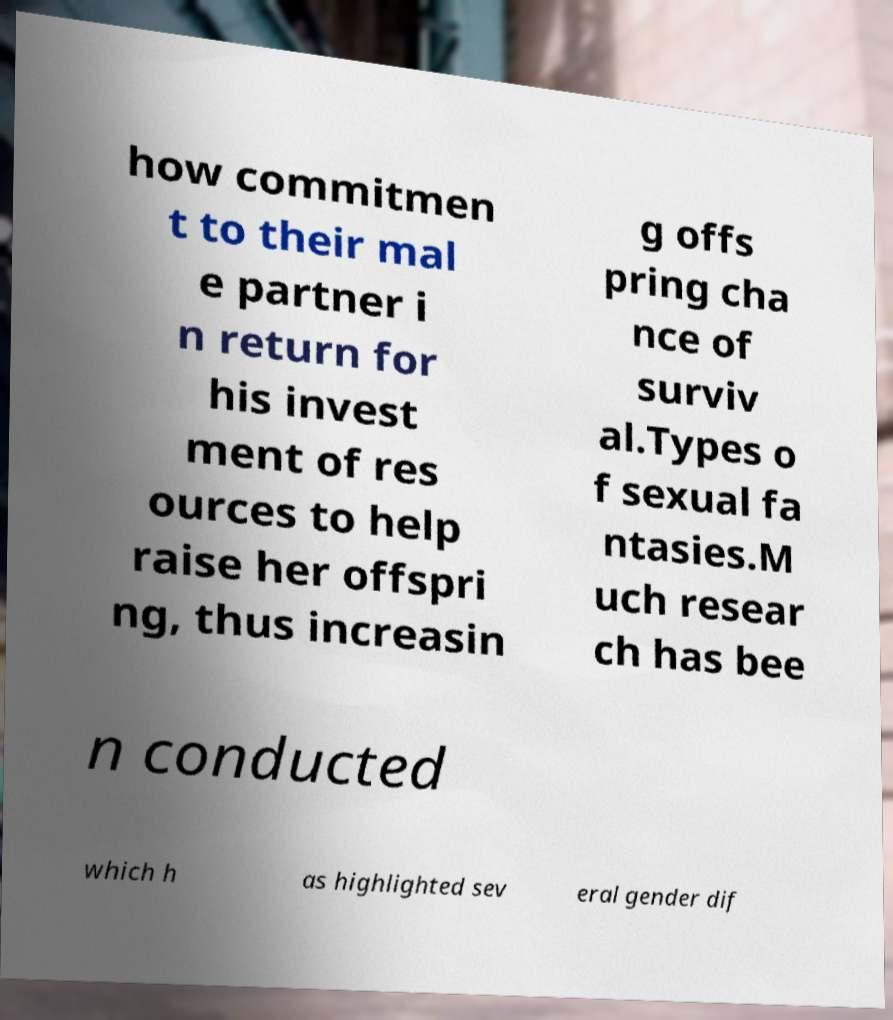What messages or text are displayed in this image? I need them in a readable, typed format. how commitmen t to their mal e partner i n return for his invest ment of res ources to help raise her offspri ng, thus increasin g offs pring cha nce of surviv al.Types o f sexual fa ntasies.M uch resear ch has bee n conducted which h as highlighted sev eral gender dif 